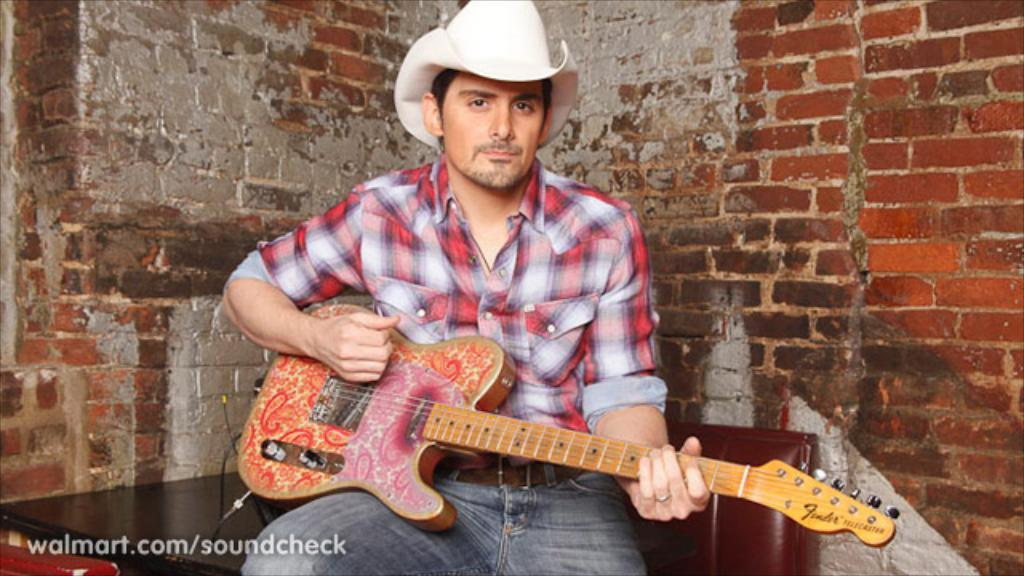Who is the main subject in the image? There is a man in the image. What is the man doing in the image? The man is sitting on a table. What object is the man holding in the image? The man is holding a guitar in his hand. How many kittens are playing with the egg on the table in the image? There are no kittens or eggs present in the image; it features a man sitting on a table and holding a guitar. 